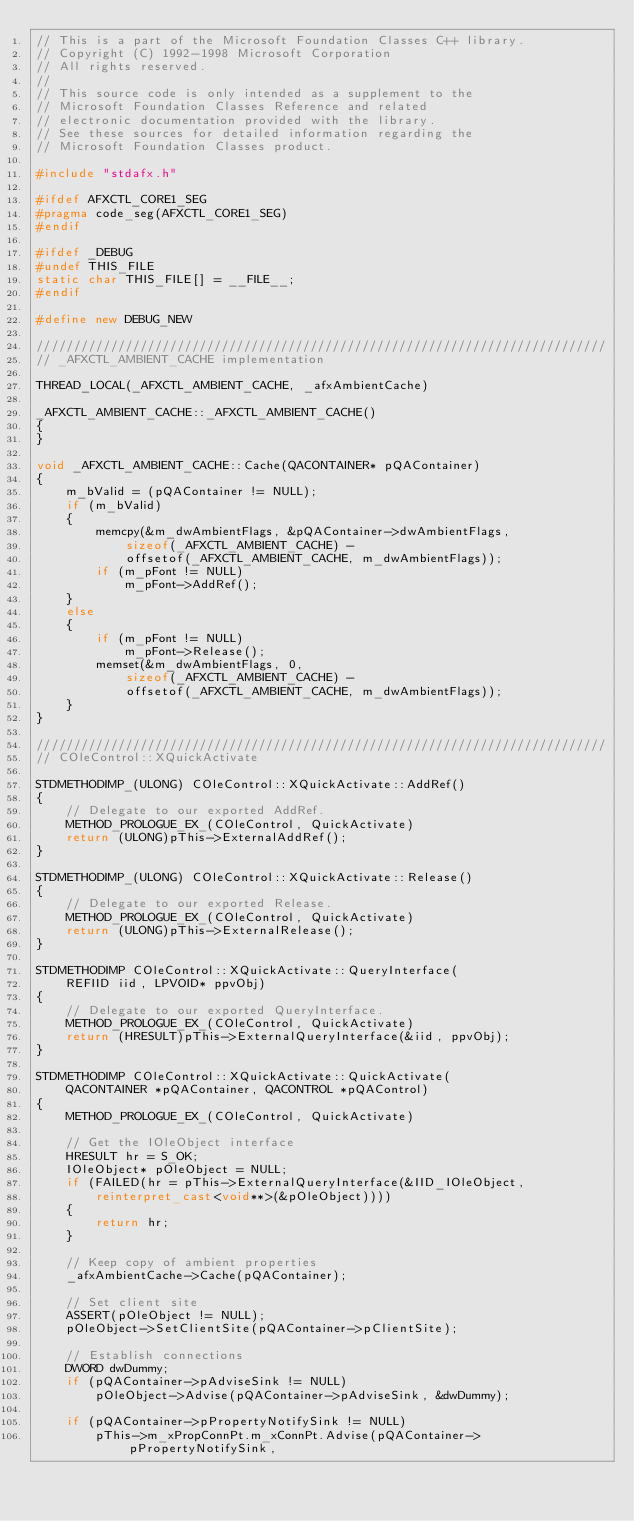Convert code to text. <code><loc_0><loc_0><loc_500><loc_500><_C++_>// This is a part of the Microsoft Foundation Classes C++ library.
// Copyright (C) 1992-1998 Microsoft Corporation
// All rights reserved.
//
// This source code is only intended as a supplement to the
// Microsoft Foundation Classes Reference and related
// electronic documentation provided with the library.
// See these sources for detailed information regarding the
// Microsoft Foundation Classes product.

#include "stdafx.h"

#ifdef AFXCTL_CORE1_SEG
#pragma code_seg(AFXCTL_CORE1_SEG)
#endif

#ifdef _DEBUG
#undef THIS_FILE
static char THIS_FILE[] = __FILE__;
#endif

#define new DEBUG_NEW

/////////////////////////////////////////////////////////////////////////////
// _AFXCTL_AMBIENT_CACHE implementation

THREAD_LOCAL(_AFXCTL_AMBIENT_CACHE, _afxAmbientCache)

_AFXCTL_AMBIENT_CACHE::_AFXCTL_AMBIENT_CACHE()
{
}

void _AFXCTL_AMBIENT_CACHE::Cache(QACONTAINER* pQAContainer)
{
	m_bValid = (pQAContainer != NULL);
	if (m_bValid)
	{
		memcpy(&m_dwAmbientFlags, &pQAContainer->dwAmbientFlags,
			sizeof(_AFXCTL_AMBIENT_CACHE) -
			offsetof(_AFXCTL_AMBIENT_CACHE, m_dwAmbientFlags));
		if (m_pFont != NULL)
			m_pFont->AddRef();
	}
	else
	{
		if (m_pFont != NULL)
			m_pFont->Release();
		memset(&m_dwAmbientFlags, 0,
			sizeof(_AFXCTL_AMBIENT_CACHE) -
			offsetof(_AFXCTL_AMBIENT_CACHE, m_dwAmbientFlags));
	}
}

/////////////////////////////////////////////////////////////////////////////
// COleControl::XQuickActivate

STDMETHODIMP_(ULONG) COleControl::XQuickActivate::AddRef()
{
	// Delegate to our exported AddRef.
	METHOD_PROLOGUE_EX_(COleControl, QuickActivate)
	return (ULONG)pThis->ExternalAddRef();
}

STDMETHODIMP_(ULONG) COleControl::XQuickActivate::Release()
{
	// Delegate to our exported Release.
	METHOD_PROLOGUE_EX_(COleControl, QuickActivate)
	return (ULONG)pThis->ExternalRelease();
}

STDMETHODIMP COleControl::XQuickActivate::QueryInterface(
	REFIID iid, LPVOID* ppvObj)
{
	// Delegate to our exported QueryInterface.
	METHOD_PROLOGUE_EX_(COleControl, QuickActivate)
	return (HRESULT)pThis->ExternalQueryInterface(&iid, ppvObj);
}

STDMETHODIMP COleControl::XQuickActivate::QuickActivate(
	QACONTAINER *pQAContainer, QACONTROL *pQAControl)
{
	METHOD_PROLOGUE_EX_(COleControl, QuickActivate)

	// Get the IOleObject interface
	HRESULT hr = S_OK;
	IOleObject* pOleObject = NULL;
	if (FAILED(hr = pThis->ExternalQueryInterface(&IID_IOleObject,
		reinterpret_cast<void**>(&pOleObject))))
	{
		return hr;
	}

	// Keep copy of ambient properties
	_afxAmbientCache->Cache(pQAContainer);

	// Set client site
	ASSERT(pOleObject != NULL);
	pOleObject->SetClientSite(pQAContainer->pClientSite);

	// Establish connections
	DWORD dwDummy;
	if (pQAContainer->pAdviseSink != NULL)
		pOleObject->Advise(pQAContainer->pAdviseSink, &dwDummy);

	if (pQAContainer->pPropertyNotifySink != NULL)
		pThis->m_xPropConnPt.m_xConnPt.Advise(pQAContainer->pPropertyNotifySink,</code> 